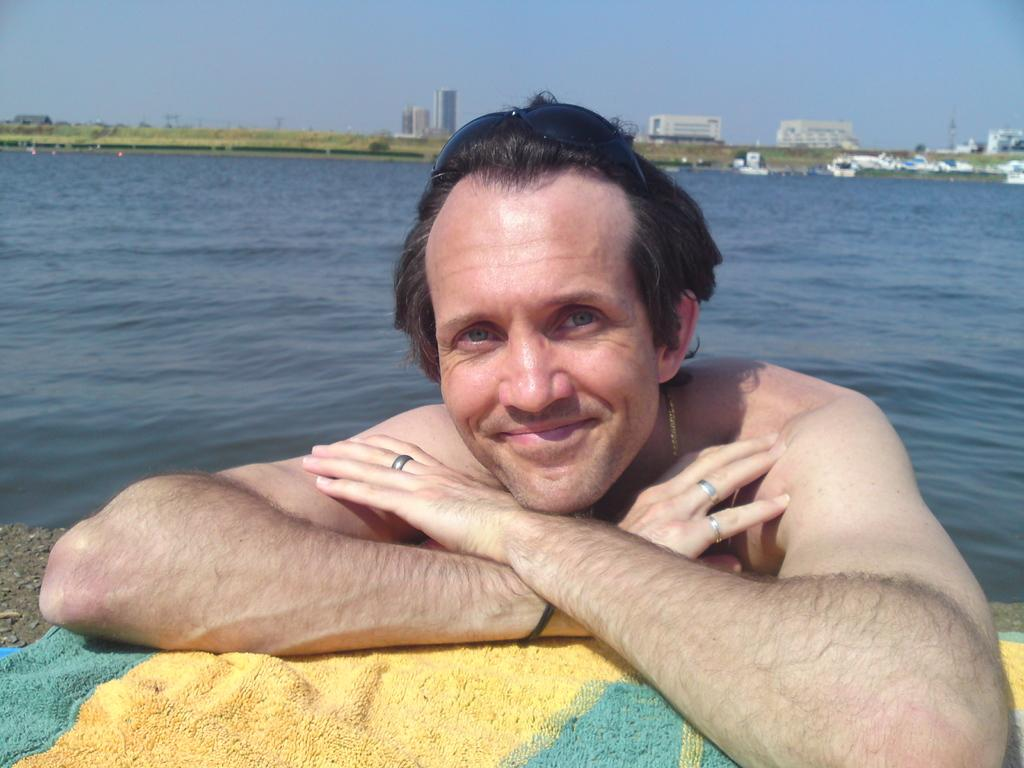What is the person in the image doing in the water? The person is in the water and is smiling. What is the person leaning on in the image? The person is leaning on a cloth. What colors are present on the cloth? The cloth is yellow and green in color. What can be seen in the background of the image? There is a sea and buildings in the background of the image. How many pets does the person have in the image? There are no pets visible in the image. What type of balls can be seen in the image? There are no balls present in the image. 